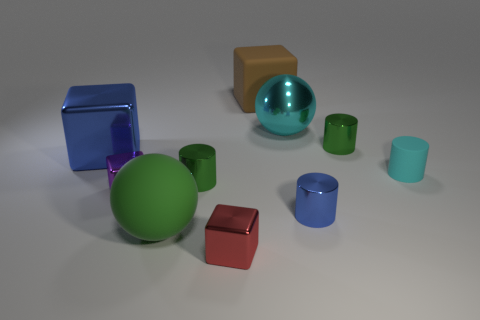How many matte things are the same color as the large metallic block?
Offer a very short reply. 0. What number of things are large balls or small green metallic cylinders on the right side of the small blue metallic thing?
Keep it short and to the point. 3. Do the blue shiny block that is in front of the big brown matte object and the cyan object that is behind the tiny cyan cylinder have the same size?
Your response must be concise. Yes. Are there any cyan cubes that have the same material as the green sphere?
Make the answer very short. No. What is the shape of the brown matte object?
Your answer should be compact. Cube. There is a big rubber thing on the right side of the small green metal thing that is in front of the tiny cyan cylinder; what is its shape?
Provide a succinct answer. Cube. What number of other objects are there of the same shape as the purple thing?
Make the answer very short. 3. There is a shiny cylinder behind the small cylinder that is to the left of the big brown object; how big is it?
Your answer should be compact. Small. Are any red metal blocks visible?
Give a very brief answer. Yes. What number of large metal spheres are behind the shiny block in front of the purple metallic cube?
Give a very brief answer. 1. 